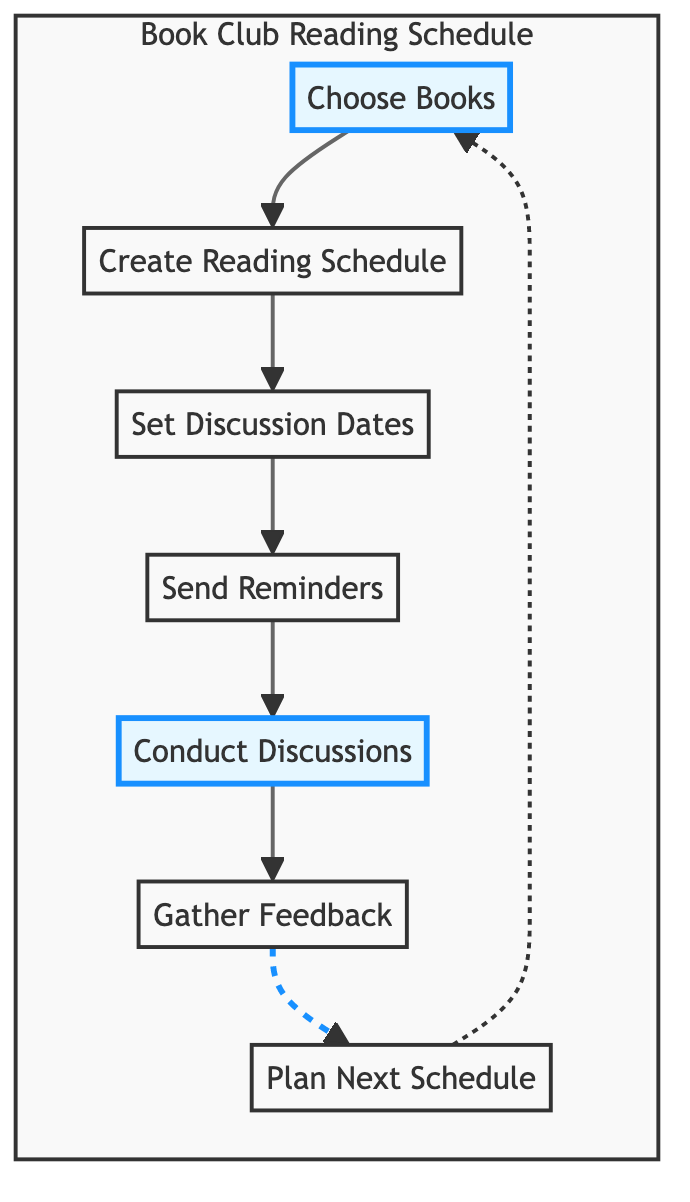What is the first step in the reading schedule flow? The diagram indicates that the first step in the flow is to "Choose Books." This is derived directly from the starting node in the flowchart.
Answer: Choose Books How many main steps are listed in the reading schedule? By counting the nodes in the flowchart, we can see that there are a total of seven main steps involved in the process outlined.
Answer: Seven What follows after "Create Reading Schedule"? The flowchart shows that the step that follows "Create Reading Schedule" is "Set Discussion Dates." This is determined by looking at the arrows connecting the nodes.
Answer: Set Discussion Dates What step comes before "Conduct Discussions"? In the flow, "Send Reminders" is the step that comes immediately before "Conduct Discussions," as represented by the arrow connecting the two nodes.
Answer: Send Reminders Which steps are highlighted in the diagram? The steps "Choose Books" and "Conduct Discussions" are highlighted in the diagram. The highlighting can be identified by the special style applied to these specific nodes.
Answer: Choose Books and Conduct Discussions What is the last step in the reading schedule flow? According to the flowchart, the last step in the reading schedule process is "Plan Next Schedule," as it is the final node in the sequence.
Answer: Plan Next Schedule How does the flowchart indicate feedback is gathered? The flowchart indicates that after "Conduct Discussions," the next step is to "Gather Feedback," which shows the process of collecting opinions after discussions.
Answer: Gather Feedback What is the relationship between "Gather Feedback" and "Plan Next Schedule"? The flowchart demonstrates a sequential relationship where "Gather Feedback" leads directly into "Plan Next Schedule," indicating that feedback informs the planning of future schedules.
Answer: Directly leads to 